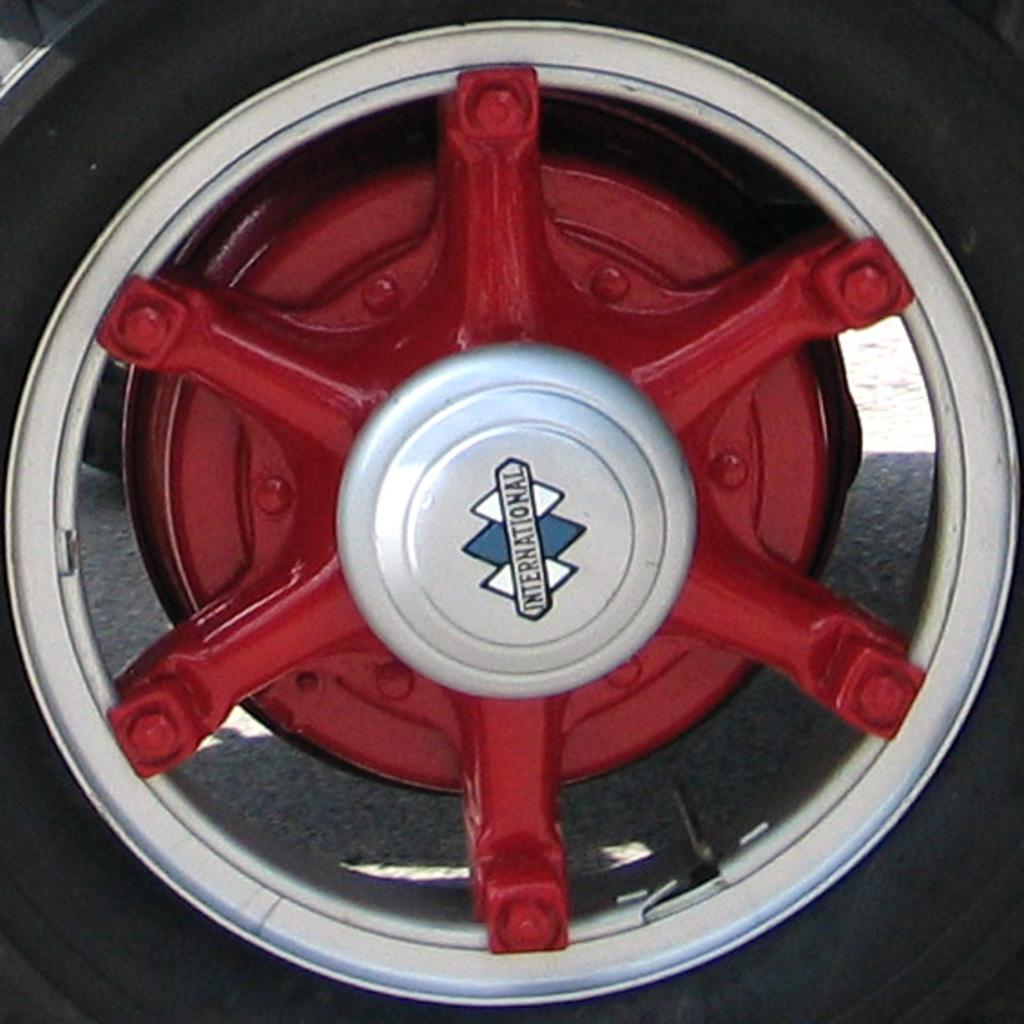What is the color of the object in the image? The object in the image is red and silver colored. What can be found on the surface of the object? There is writing on the object. What is the cause of death for the person playing volleyball in the image? There is no person playing volleyball in the image, and therefore no cause of death can be determined. 